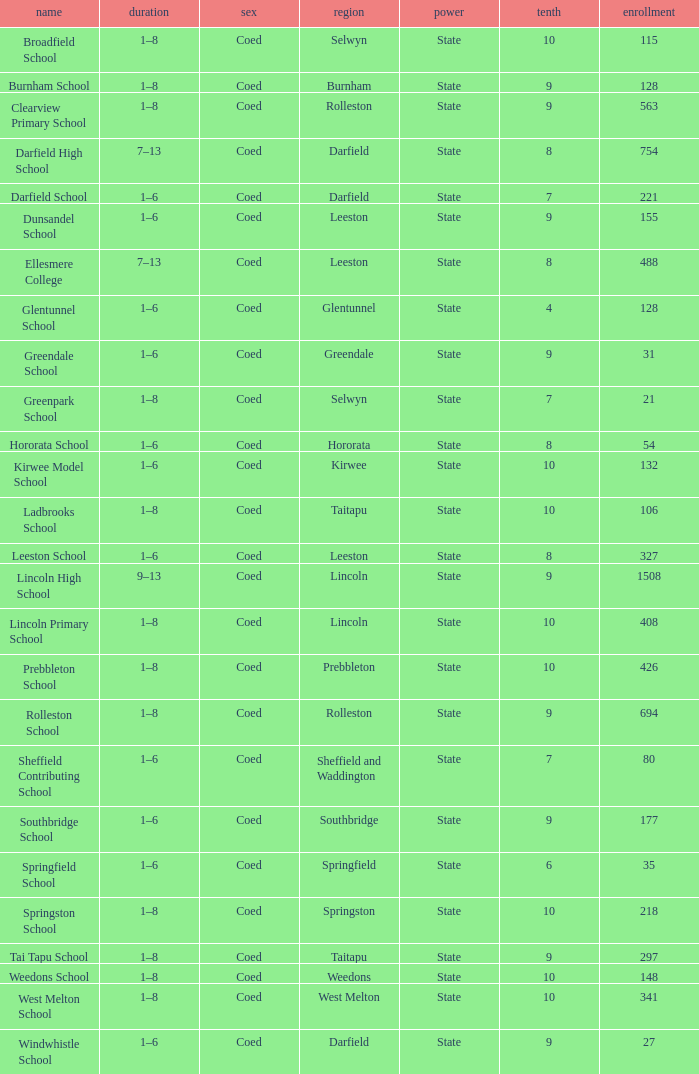How many deciles have Years of 9–13? 1.0. 